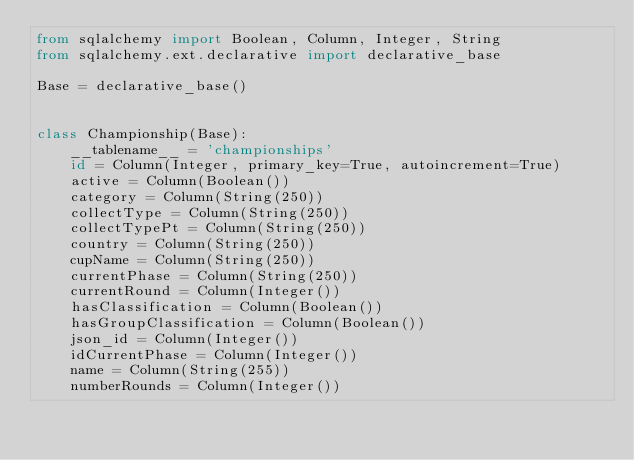<code> <loc_0><loc_0><loc_500><loc_500><_Python_>from sqlalchemy import Boolean, Column, Integer, String
from sqlalchemy.ext.declarative import declarative_base

Base = declarative_base()


class Championship(Base):
    __tablename__ = 'championships'
    id = Column(Integer, primary_key=True, autoincrement=True)
    active = Column(Boolean())
    category = Column(String(250))
    collectType = Column(String(250))
    collectTypePt = Column(String(250))
    country = Column(String(250))
    cupName = Column(String(250))
    currentPhase = Column(String(250))
    currentRound = Column(Integer())
    hasClassification = Column(Boolean())
    hasGroupClassification = Column(Boolean())
    json_id = Column(Integer())
    idCurrentPhase = Column(Integer())
    name = Column(String(255))
    numberRounds = Column(Integer())
</code> 